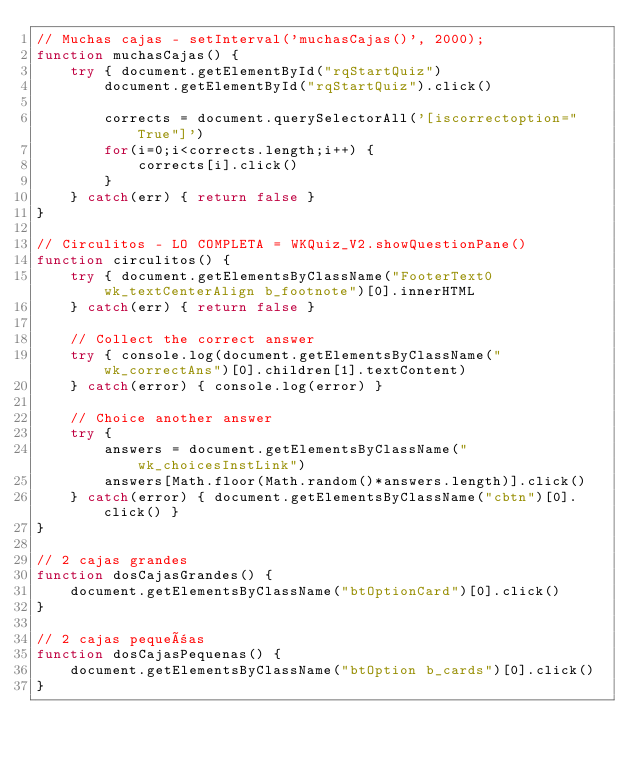<code> <loc_0><loc_0><loc_500><loc_500><_JavaScript_>// Muchas cajas - setInterval('muchasCajas()', 2000);
function muchasCajas() {
    try { document.getElementById("rqStartQuiz")
        document.getElementById("rqStartQuiz").click()

        corrects = document.querySelectorAll('[iscorrectoption="True"]')
        for(i=0;i<corrects.length;i++) {
            corrects[i].click()
        }
    } catch(err) { return false }
}

// Circulitos - LO COMPLETA = WKQuiz_V2.showQuestionPane()
function circulitos() {
    try { document.getElementsByClassName("FooterText0 wk_textCenterAlign b_footnote")[0].innerHTML
    } catch(err) { return false }

    // Collect the correct answer
    try { console.log(document.getElementsByClassName("wk_correctAns")[0].children[1].textContent)
    } catch(error) { console.log(error) }

    // Choice another answer
    try {
        answers = document.getElementsByClassName("wk_choicesInstLink")
        answers[Math.floor(Math.random()*answers.length)].click()
    } catch(error) { document.getElementsByClassName("cbtn")[0].click() }
}

// 2 cajas grandes
function dosCajasGrandes() {
    document.getElementsByClassName("btOptionCard")[0].click()
}

// 2 cajas pequeñas
function dosCajasPequenas() {
    document.getElementsByClassName("btOption b_cards")[0].click()
}

</code> 